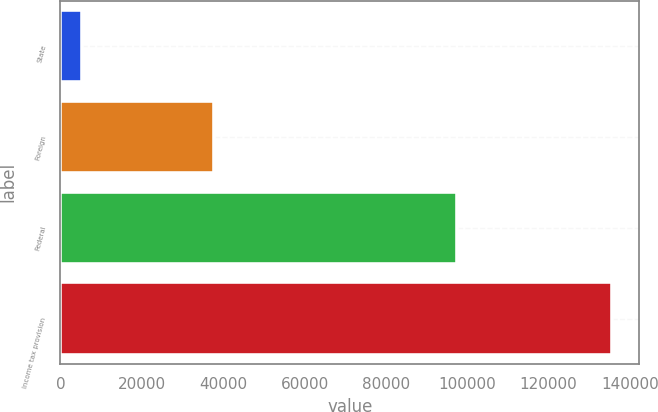Convert chart. <chart><loc_0><loc_0><loc_500><loc_500><bar_chart><fcel>State<fcel>Foreign<fcel>Federal<fcel>Income tax provision<nl><fcel>5207<fcel>37789<fcel>97528<fcel>135509<nl></chart> 